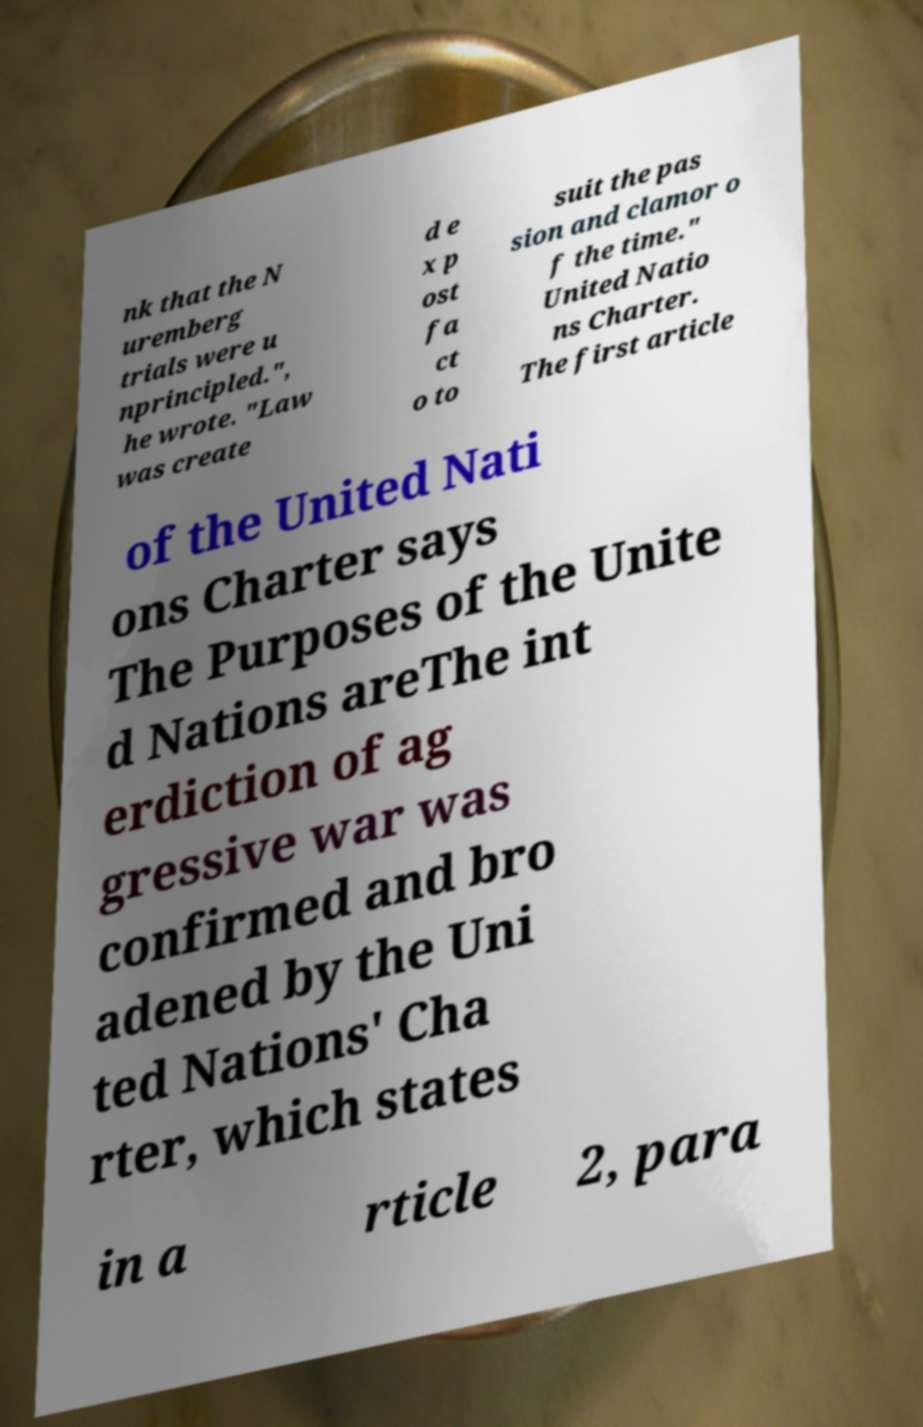Please read and relay the text visible in this image. What does it say? nk that the N uremberg trials were u nprincipled.", he wrote. "Law was create d e x p ost fa ct o to suit the pas sion and clamor o f the time." United Natio ns Charter. The first article of the United Nati ons Charter says The Purposes of the Unite d Nations areThe int erdiction of ag gressive war was confirmed and bro adened by the Uni ted Nations' Cha rter, which states in a rticle 2, para 